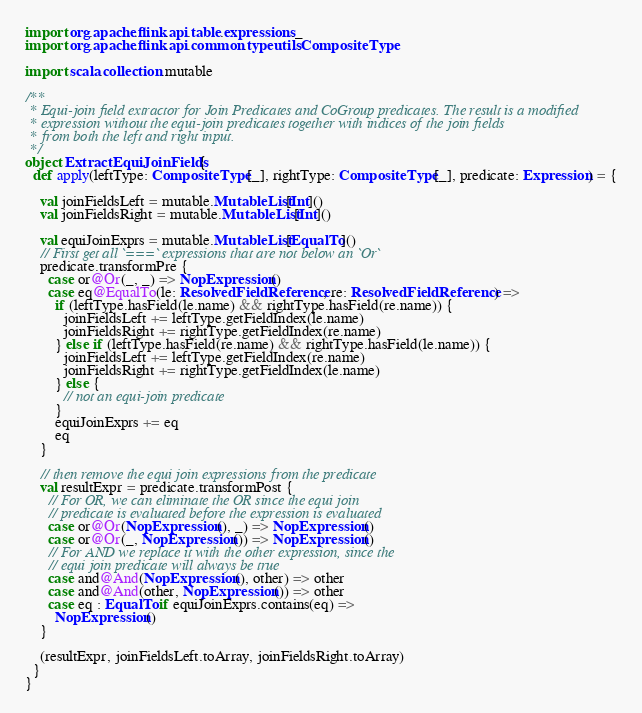Convert code to text. <code><loc_0><loc_0><loc_500><loc_500><_Scala_>import org.apache.flink.api.table.expressions._
import org.apache.flink.api.common.typeutils.CompositeType

import scala.collection.mutable

/**
 * Equi-join field extractor for Join Predicates and CoGroup predicates. The result is a modified
 * expression without the equi-join predicates together with indices of the join fields
 * from both the left and right input.
 */
object ExtractEquiJoinFields {
  def apply(leftType: CompositeType[_], rightType: CompositeType[_], predicate: Expression) = {

    val joinFieldsLeft = mutable.MutableList[Int]()
    val joinFieldsRight = mutable.MutableList[Int]()

    val equiJoinExprs = mutable.MutableList[EqualTo]()
    // First get all `===` expressions that are not below an `Or`
    predicate.transformPre {
      case or@Or(_, _) => NopExpression()
      case eq@EqualTo(le: ResolvedFieldReference, re: ResolvedFieldReference) =>
        if (leftType.hasField(le.name) && rightType.hasField(re.name)) {
          joinFieldsLeft += leftType.getFieldIndex(le.name)
          joinFieldsRight += rightType.getFieldIndex(re.name)
        } else if (leftType.hasField(re.name) && rightType.hasField(le.name)) {
          joinFieldsLeft += leftType.getFieldIndex(re.name)
          joinFieldsRight += rightType.getFieldIndex(le.name)
        } else {
          // not an equi-join predicate
        }
        equiJoinExprs += eq
        eq
    }

    // then remove the equi join expressions from the predicate
    val resultExpr = predicate.transformPost {
      // For OR, we can eliminate the OR since the equi join
      // predicate is evaluated before the expression is evaluated
      case or@Or(NopExpression(), _) => NopExpression()
      case or@Or(_, NopExpression()) => NopExpression()
      // For AND we replace it with the other expression, since the
      // equi join predicate will always be true
      case and@And(NopExpression(), other) => other
      case and@And(other, NopExpression()) => other
      case eq : EqualTo if equiJoinExprs.contains(eq) =>
        NopExpression()
    }

    (resultExpr, joinFieldsLeft.toArray, joinFieldsRight.toArray)
  }
}
</code> 